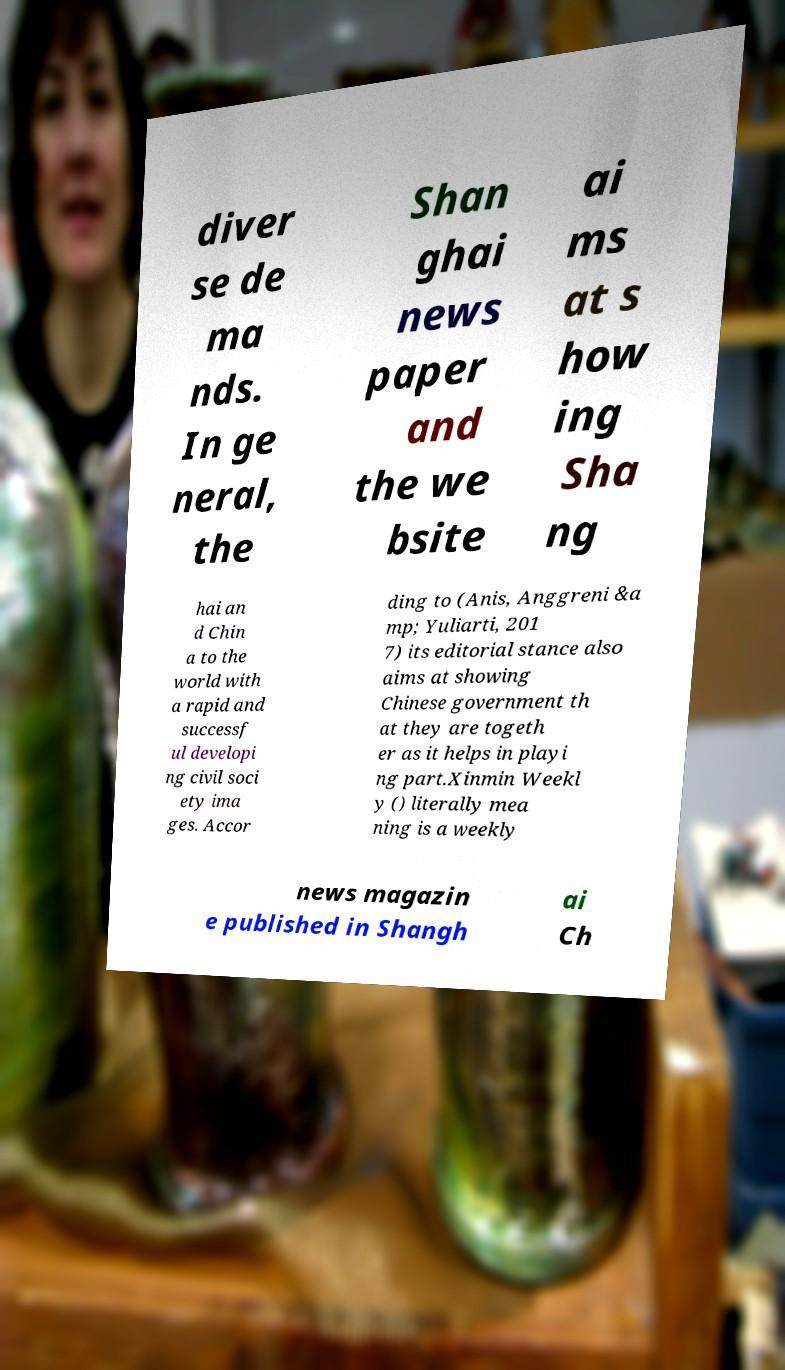I need the written content from this picture converted into text. Can you do that? diver se de ma nds. In ge neral, the Shan ghai news paper and the we bsite ai ms at s how ing Sha ng hai an d Chin a to the world with a rapid and successf ul developi ng civil soci ety ima ges. Accor ding to (Anis, Anggreni &a mp; Yuliarti, 201 7) its editorial stance also aims at showing Chinese government th at they are togeth er as it helps in playi ng part.Xinmin Weekl y () literally mea ning is a weekly news magazin e published in Shangh ai Ch 